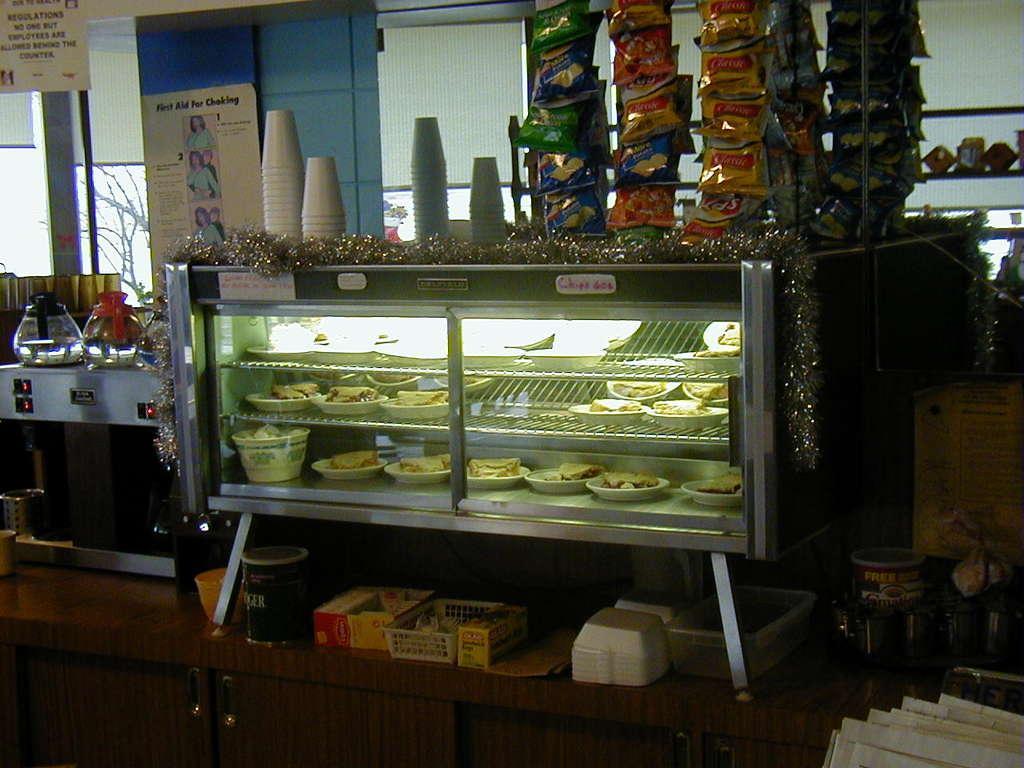Please provide a concise description of this image. In this image there is a cabinet, in which there are some plates, foods, on the cabinet there are glasses, the cabinet kept on cup boards, on which there are some objects, bowls, baskets, poster is attached to the wall at the top on which there is a text and images, on the left side there is a window. 